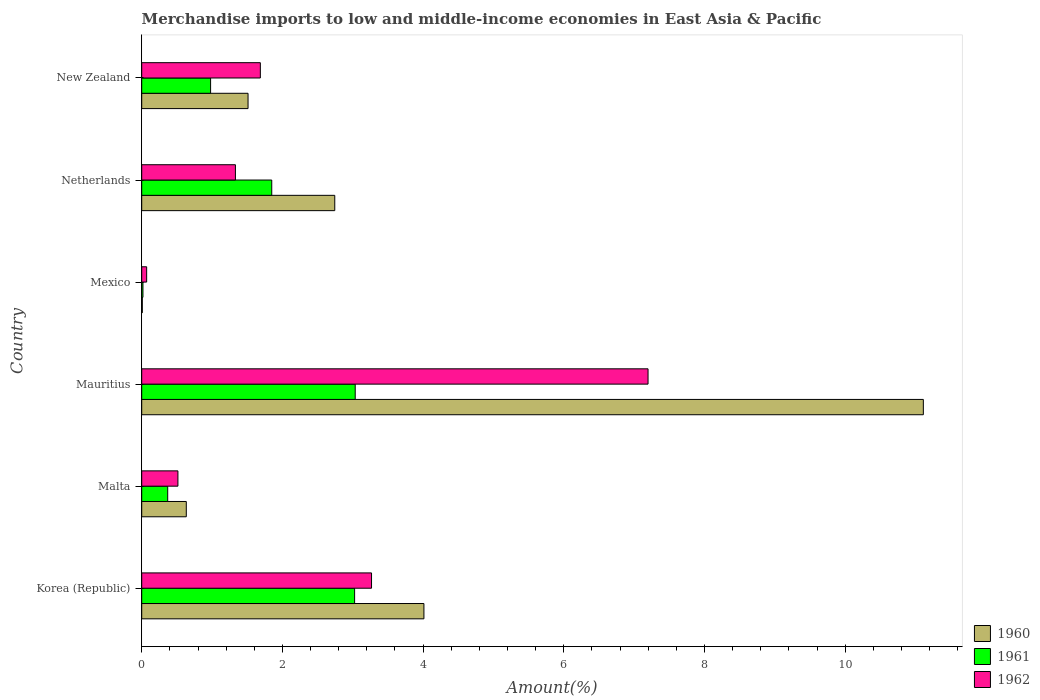How many different coloured bars are there?
Provide a succinct answer. 3. Are the number of bars on each tick of the Y-axis equal?
Provide a short and direct response. Yes. In how many cases, is the number of bars for a given country not equal to the number of legend labels?
Your answer should be very brief. 0. What is the percentage of amount earned from merchandise imports in 1961 in Netherlands?
Provide a short and direct response. 1.85. Across all countries, what is the maximum percentage of amount earned from merchandise imports in 1961?
Your response must be concise. 3.03. Across all countries, what is the minimum percentage of amount earned from merchandise imports in 1961?
Provide a succinct answer. 0.02. In which country was the percentage of amount earned from merchandise imports in 1960 maximum?
Your response must be concise. Mauritius. In which country was the percentage of amount earned from merchandise imports in 1961 minimum?
Provide a succinct answer. Mexico. What is the total percentage of amount earned from merchandise imports in 1960 in the graph?
Offer a terse response. 20.02. What is the difference between the percentage of amount earned from merchandise imports in 1961 in Malta and that in Netherlands?
Your answer should be compact. -1.48. What is the difference between the percentage of amount earned from merchandise imports in 1960 in Mexico and the percentage of amount earned from merchandise imports in 1961 in Korea (Republic)?
Your answer should be compact. -3.02. What is the average percentage of amount earned from merchandise imports in 1961 per country?
Your answer should be very brief. 1.55. What is the difference between the percentage of amount earned from merchandise imports in 1960 and percentage of amount earned from merchandise imports in 1961 in Netherlands?
Ensure brevity in your answer.  0.9. What is the ratio of the percentage of amount earned from merchandise imports in 1961 in Korea (Republic) to that in Mexico?
Ensure brevity in your answer.  171.92. Is the percentage of amount earned from merchandise imports in 1962 in Malta less than that in Mexico?
Provide a succinct answer. No. What is the difference between the highest and the second highest percentage of amount earned from merchandise imports in 1961?
Keep it short and to the point. 0.01. What is the difference between the highest and the lowest percentage of amount earned from merchandise imports in 1962?
Ensure brevity in your answer.  7.13. In how many countries, is the percentage of amount earned from merchandise imports in 1961 greater than the average percentage of amount earned from merchandise imports in 1961 taken over all countries?
Provide a short and direct response. 3. Are all the bars in the graph horizontal?
Your response must be concise. Yes. What is the difference between two consecutive major ticks on the X-axis?
Offer a very short reply. 2. Does the graph contain any zero values?
Provide a succinct answer. No. Where does the legend appear in the graph?
Provide a short and direct response. Bottom right. How are the legend labels stacked?
Make the answer very short. Vertical. What is the title of the graph?
Provide a succinct answer. Merchandise imports to low and middle-income economies in East Asia & Pacific. Does "1971" appear as one of the legend labels in the graph?
Provide a succinct answer. No. What is the label or title of the X-axis?
Your answer should be very brief. Amount(%). What is the Amount(%) in 1960 in Korea (Republic)?
Your response must be concise. 4.01. What is the Amount(%) of 1961 in Korea (Republic)?
Keep it short and to the point. 3.03. What is the Amount(%) in 1962 in Korea (Republic)?
Your answer should be compact. 3.27. What is the Amount(%) in 1960 in Malta?
Your answer should be very brief. 0.63. What is the Amount(%) in 1961 in Malta?
Keep it short and to the point. 0.37. What is the Amount(%) in 1962 in Malta?
Offer a terse response. 0.51. What is the Amount(%) of 1960 in Mauritius?
Ensure brevity in your answer.  11.11. What is the Amount(%) in 1961 in Mauritius?
Provide a short and direct response. 3.03. What is the Amount(%) of 1962 in Mauritius?
Offer a terse response. 7.2. What is the Amount(%) of 1960 in Mexico?
Offer a terse response. 0.01. What is the Amount(%) in 1961 in Mexico?
Offer a terse response. 0.02. What is the Amount(%) of 1962 in Mexico?
Provide a short and direct response. 0.07. What is the Amount(%) of 1960 in Netherlands?
Your answer should be very brief. 2.74. What is the Amount(%) of 1961 in Netherlands?
Keep it short and to the point. 1.85. What is the Amount(%) in 1962 in Netherlands?
Provide a succinct answer. 1.33. What is the Amount(%) in 1960 in New Zealand?
Ensure brevity in your answer.  1.51. What is the Amount(%) of 1961 in New Zealand?
Keep it short and to the point. 0.98. What is the Amount(%) of 1962 in New Zealand?
Make the answer very short. 1.69. Across all countries, what is the maximum Amount(%) of 1960?
Keep it short and to the point. 11.11. Across all countries, what is the maximum Amount(%) in 1961?
Keep it short and to the point. 3.03. Across all countries, what is the maximum Amount(%) in 1962?
Provide a short and direct response. 7.2. Across all countries, what is the minimum Amount(%) in 1960?
Offer a very short reply. 0.01. Across all countries, what is the minimum Amount(%) in 1961?
Offer a terse response. 0.02. Across all countries, what is the minimum Amount(%) of 1962?
Ensure brevity in your answer.  0.07. What is the total Amount(%) in 1960 in the graph?
Offer a terse response. 20.02. What is the total Amount(%) of 1961 in the graph?
Offer a very short reply. 9.28. What is the total Amount(%) in 1962 in the graph?
Provide a short and direct response. 14.07. What is the difference between the Amount(%) of 1960 in Korea (Republic) and that in Malta?
Ensure brevity in your answer.  3.38. What is the difference between the Amount(%) in 1961 in Korea (Republic) and that in Malta?
Your answer should be compact. 2.66. What is the difference between the Amount(%) in 1962 in Korea (Republic) and that in Malta?
Provide a short and direct response. 2.75. What is the difference between the Amount(%) of 1960 in Korea (Republic) and that in Mauritius?
Offer a terse response. -7.1. What is the difference between the Amount(%) in 1961 in Korea (Republic) and that in Mauritius?
Offer a very short reply. -0.01. What is the difference between the Amount(%) of 1962 in Korea (Republic) and that in Mauritius?
Your response must be concise. -3.93. What is the difference between the Amount(%) of 1960 in Korea (Republic) and that in Mexico?
Your answer should be very brief. 4. What is the difference between the Amount(%) in 1961 in Korea (Republic) and that in Mexico?
Provide a succinct answer. 3.01. What is the difference between the Amount(%) in 1962 in Korea (Republic) and that in Mexico?
Provide a succinct answer. 3.2. What is the difference between the Amount(%) in 1960 in Korea (Republic) and that in Netherlands?
Provide a short and direct response. 1.27. What is the difference between the Amount(%) in 1961 in Korea (Republic) and that in Netherlands?
Keep it short and to the point. 1.18. What is the difference between the Amount(%) in 1962 in Korea (Republic) and that in Netherlands?
Your answer should be very brief. 1.94. What is the difference between the Amount(%) in 1961 in Korea (Republic) and that in New Zealand?
Your response must be concise. 2.05. What is the difference between the Amount(%) in 1962 in Korea (Republic) and that in New Zealand?
Provide a succinct answer. 1.58. What is the difference between the Amount(%) of 1960 in Malta and that in Mauritius?
Give a very brief answer. -10.48. What is the difference between the Amount(%) in 1961 in Malta and that in Mauritius?
Ensure brevity in your answer.  -2.67. What is the difference between the Amount(%) of 1962 in Malta and that in Mauritius?
Provide a short and direct response. -6.68. What is the difference between the Amount(%) in 1960 in Malta and that in Mexico?
Your response must be concise. 0.63. What is the difference between the Amount(%) of 1961 in Malta and that in Mexico?
Ensure brevity in your answer.  0.35. What is the difference between the Amount(%) in 1962 in Malta and that in Mexico?
Offer a terse response. 0.44. What is the difference between the Amount(%) in 1960 in Malta and that in Netherlands?
Provide a short and direct response. -2.11. What is the difference between the Amount(%) in 1961 in Malta and that in Netherlands?
Offer a very short reply. -1.48. What is the difference between the Amount(%) in 1962 in Malta and that in Netherlands?
Provide a succinct answer. -0.82. What is the difference between the Amount(%) in 1960 in Malta and that in New Zealand?
Provide a short and direct response. -0.88. What is the difference between the Amount(%) of 1961 in Malta and that in New Zealand?
Your answer should be very brief. -0.61. What is the difference between the Amount(%) of 1962 in Malta and that in New Zealand?
Your answer should be compact. -1.17. What is the difference between the Amount(%) in 1960 in Mauritius and that in Mexico?
Ensure brevity in your answer.  11.1. What is the difference between the Amount(%) of 1961 in Mauritius and that in Mexico?
Offer a terse response. 3.02. What is the difference between the Amount(%) in 1962 in Mauritius and that in Mexico?
Your answer should be very brief. 7.13. What is the difference between the Amount(%) in 1960 in Mauritius and that in Netherlands?
Make the answer very short. 8.37. What is the difference between the Amount(%) in 1961 in Mauritius and that in Netherlands?
Your answer should be very brief. 1.19. What is the difference between the Amount(%) of 1962 in Mauritius and that in Netherlands?
Ensure brevity in your answer.  5.87. What is the difference between the Amount(%) of 1960 in Mauritius and that in New Zealand?
Offer a terse response. 9.6. What is the difference between the Amount(%) in 1961 in Mauritius and that in New Zealand?
Keep it short and to the point. 2.06. What is the difference between the Amount(%) in 1962 in Mauritius and that in New Zealand?
Ensure brevity in your answer.  5.51. What is the difference between the Amount(%) in 1960 in Mexico and that in Netherlands?
Make the answer very short. -2.74. What is the difference between the Amount(%) in 1961 in Mexico and that in Netherlands?
Your answer should be compact. -1.83. What is the difference between the Amount(%) of 1962 in Mexico and that in Netherlands?
Give a very brief answer. -1.26. What is the difference between the Amount(%) in 1960 in Mexico and that in New Zealand?
Offer a terse response. -1.5. What is the difference between the Amount(%) of 1961 in Mexico and that in New Zealand?
Offer a very short reply. -0.96. What is the difference between the Amount(%) of 1962 in Mexico and that in New Zealand?
Give a very brief answer. -1.62. What is the difference between the Amount(%) of 1960 in Netherlands and that in New Zealand?
Your answer should be compact. 1.23. What is the difference between the Amount(%) in 1961 in Netherlands and that in New Zealand?
Make the answer very short. 0.87. What is the difference between the Amount(%) of 1962 in Netherlands and that in New Zealand?
Keep it short and to the point. -0.35. What is the difference between the Amount(%) in 1960 in Korea (Republic) and the Amount(%) in 1961 in Malta?
Provide a short and direct response. 3.64. What is the difference between the Amount(%) of 1960 in Korea (Republic) and the Amount(%) of 1962 in Malta?
Make the answer very short. 3.5. What is the difference between the Amount(%) in 1961 in Korea (Republic) and the Amount(%) in 1962 in Malta?
Ensure brevity in your answer.  2.51. What is the difference between the Amount(%) of 1960 in Korea (Republic) and the Amount(%) of 1961 in Mauritius?
Your answer should be very brief. 0.98. What is the difference between the Amount(%) of 1960 in Korea (Republic) and the Amount(%) of 1962 in Mauritius?
Ensure brevity in your answer.  -3.19. What is the difference between the Amount(%) of 1961 in Korea (Republic) and the Amount(%) of 1962 in Mauritius?
Provide a succinct answer. -4.17. What is the difference between the Amount(%) of 1960 in Korea (Republic) and the Amount(%) of 1961 in Mexico?
Give a very brief answer. 3.99. What is the difference between the Amount(%) in 1960 in Korea (Republic) and the Amount(%) in 1962 in Mexico?
Your answer should be compact. 3.94. What is the difference between the Amount(%) in 1961 in Korea (Republic) and the Amount(%) in 1962 in Mexico?
Keep it short and to the point. 2.96. What is the difference between the Amount(%) of 1960 in Korea (Republic) and the Amount(%) of 1961 in Netherlands?
Your answer should be very brief. 2.16. What is the difference between the Amount(%) in 1960 in Korea (Republic) and the Amount(%) in 1962 in Netherlands?
Your response must be concise. 2.68. What is the difference between the Amount(%) in 1961 in Korea (Republic) and the Amount(%) in 1962 in Netherlands?
Your answer should be compact. 1.69. What is the difference between the Amount(%) of 1960 in Korea (Republic) and the Amount(%) of 1961 in New Zealand?
Provide a succinct answer. 3.03. What is the difference between the Amount(%) of 1960 in Korea (Republic) and the Amount(%) of 1962 in New Zealand?
Provide a succinct answer. 2.33. What is the difference between the Amount(%) in 1961 in Korea (Republic) and the Amount(%) in 1962 in New Zealand?
Keep it short and to the point. 1.34. What is the difference between the Amount(%) of 1960 in Malta and the Amount(%) of 1961 in Mauritius?
Make the answer very short. -2.4. What is the difference between the Amount(%) of 1960 in Malta and the Amount(%) of 1962 in Mauritius?
Keep it short and to the point. -6.56. What is the difference between the Amount(%) of 1961 in Malta and the Amount(%) of 1962 in Mauritius?
Ensure brevity in your answer.  -6.83. What is the difference between the Amount(%) of 1960 in Malta and the Amount(%) of 1961 in Mexico?
Your response must be concise. 0.62. What is the difference between the Amount(%) in 1960 in Malta and the Amount(%) in 1962 in Mexico?
Offer a very short reply. 0.56. What is the difference between the Amount(%) of 1961 in Malta and the Amount(%) of 1962 in Mexico?
Make the answer very short. 0.3. What is the difference between the Amount(%) in 1960 in Malta and the Amount(%) in 1961 in Netherlands?
Make the answer very short. -1.21. What is the difference between the Amount(%) of 1960 in Malta and the Amount(%) of 1962 in Netherlands?
Give a very brief answer. -0.7. What is the difference between the Amount(%) in 1961 in Malta and the Amount(%) in 1962 in Netherlands?
Offer a very short reply. -0.96. What is the difference between the Amount(%) in 1960 in Malta and the Amount(%) in 1961 in New Zealand?
Your answer should be very brief. -0.35. What is the difference between the Amount(%) of 1960 in Malta and the Amount(%) of 1962 in New Zealand?
Provide a short and direct response. -1.05. What is the difference between the Amount(%) in 1961 in Malta and the Amount(%) in 1962 in New Zealand?
Give a very brief answer. -1.32. What is the difference between the Amount(%) in 1960 in Mauritius and the Amount(%) in 1961 in Mexico?
Ensure brevity in your answer.  11.09. What is the difference between the Amount(%) of 1960 in Mauritius and the Amount(%) of 1962 in Mexico?
Your answer should be very brief. 11.04. What is the difference between the Amount(%) of 1961 in Mauritius and the Amount(%) of 1962 in Mexico?
Offer a terse response. 2.96. What is the difference between the Amount(%) of 1960 in Mauritius and the Amount(%) of 1961 in Netherlands?
Offer a very short reply. 9.26. What is the difference between the Amount(%) in 1960 in Mauritius and the Amount(%) in 1962 in Netherlands?
Keep it short and to the point. 9.78. What is the difference between the Amount(%) in 1961 in Mauritius and the Amount(%) in 1962 in Netherlands?
Make the answer very short. 1.7. What is the difference between the Amount(%) of 1960 in Mauritius and the Amount(%) of 1961 in New Zealand?
Your answer should be very brief. 10.13. What is the difference between the Amount(%) of 1960 in Mauritius and the Amount(%) of 1962 in New Zealand?
Keep it short and to the point. 9.42. What is the difference between the Amount(%) in 1961 in Mauritius and the Amount(%) in 1962 in New Zealand?
Make the answer very short. 1.35. What is the difference between the Amount(%) in 1960 in Mexico and the Amount(%) in 1961 in Netherlands?
Provide a succinct answer. -1.84. What is the difference between the Amount(%) of 1960 in Mexico and the Amount(%) of 1962 in Netherlands?
Give a very brief answer. -1.32. What is the difference between the Amount(%) in 1961 in Mexico and the Amount(%) in 1962 in Netherlands?
Provide a succinct answer. -1.31. What is the difference between the Amount(%) in 1960 in Mexico and the Amount(%) in 1961 in New Zealand?
Your answer should be very brief. -0.97. What is the difference between the Amount(%) in 1960 in Mexico and the Amount(%) in 1962 in New Zealand?
Offer a very short reply. -1.68. What is the difference between the Amount(%) in 1961 in Mexico and the Amount(%) in 1962 in New Zealand?
Your response must be concise. -1.67. What is the difference between the Amount(%) in 1960 in Netherlands and the Amount(%) in 1961 in New Zealand?
Give a very brief answer. 1.76. What is the difference between the Amount(%) in 1960 in Netherlands and the Amount(%) in 1962 in New Zealand?
Keep it short and to the point. 1.06. What is the difference between the Amount(%) of 1961 in Netherlands and the Amount(%) of 1962 in New Zealand?
Provide a short and direct response. 0.16. What is the average Amount(%) in 1960 per country?
Give a very brief answer. 3.34. What is the average Amount(%) in 1961 per country?
Provide a succinct answer. 1.55. What is the average Amount(%) in 1962 per country?
Make the answer very short. 2.34. What is the difference between the Amount(%) of 1960 and Amount(%) of 1961 in Korea (Republic)?
Your answer should be very brief. 0.99. What is the difference between the Amount(%) in 1960 and Amount(%) in 1962 in Korea (Republic)?
Offer a very short reply. 0.74. What is the difference between the Amount(%) in 1961 and Amount(%) in 1962 in Korea (Republic)?
Keep it short and to the point. -0.24. What is the difference between the Amount(%) of 1960 and Amount(%) of 1961 in Malta?
Your response must be concise. 0.26. What is the difference between the Amount(%) in 1960 and Amount(%) in 1962 in Malta?
Keep it short and to the point. 0.12. What is the difference between the Amount(%) in 1961 and Amount(%) in 1962 in Malta?
Provide a succinct answer. -0.15. What is the difference between the Amount(%) of 1960 and Amount(%) of 1961 in Mauritius?
Your answer should be compact. 8.08. What is the difference between the Amount(%) in 1960 and Amount(%) in 1962 in Mauritius?
Your response must be concise. 3.91. What is the difference between the Amount(%) in 1961 and Amount(%) in 1962 in Mauritius?
Your answer should be compact. -4.16. What is the difference between the Amount(%) of 1960 and Amount(%) of 1961 in Mexico?
Offer a very short reply. -0.01. What is the difference between the Amount(%) of 1960 and Amount(%) of 1962 in Mexico?
Your answer should be compact. -0.06. What is the difference between the Amount(%) of 1961 and Amount(%) of 1962 in Mexico?
Give a very brief answer. -0.05. What is the difference between the Amount(%) in 1960 and Amount(%) in 1961 in Netherlands?
Offer a terse response. 0.9. What is the difference between the Amount(%) in 1960 and Amount(%) in 1962 in Netherlands?
Provide a short and direct response. 1.41. What is the difference between the Amount(%) in 1961 and Amount(%) in 1962 in Netherlands?
Offer a very short reply. 0.52. What is the difference between the Amount(%) in 1960 and Amount(%) in 1961 in New Zealand?
Provide a succinct answer. 0.53. What is the difference between the Amount(%) in 1960 and Amount(%) in 1962 in New Zealand?
Provide a succinct answer. -0.17. What is the difference between the Amount(%) of 1961 and Amount(%) of 1962 in New Zealand?
Your answer should be compact. -0.71. What is the ratio of the Amount(%) in 1960 in Korea (Republic) to that in Malta?
Make the answer very short. 6.33. What is the ratio of the Amount(%) of 1961 in Korea (Republic) to that in Malta?
Make the answer very short. 8.19. What is the ratio of the Amount(%) of 1962 in Korea (Republic) to that in Malta?
Offer a very short reply. 6.35. What is the ratio of the Amount(%) in 1960 in Korea (Republic) to that in Mauritius?
Give a very brief answer. 0.36. What is the ratio of the Amount(%) in 1961 in Korea (Republic) to that in Mauritius?
Provide a short and direct response. 1. What is the ratio of the Amount(%) of 1962 in Korea (Republic) to that in Mauritius?
Provide a short and direct response. 0.45. What is the ratio of the Amount(%) in 1960 in Korea (Republic) to that in Mexico?
Offer a very short reply. 474.6. What is the ratio of the Amount(%) of 1961 in Korea (Republic) to that in Mexico?
Offer a terse response. 171.92. What is the ratio of the Amount(%) of 1962 in Korea (Republic) to that in Mexico?
Your answer should be very brief. 46.51. What is the ratio of the Amount(%) of 1960 in Korea (Republic) to that in Netherlands?
Make the answer very short. 1.46. What is the ratio of the Amount(%) in 1961 in Korea (Republic) to that in Netherlands?
Provide a short and direct response. 1.64. What is the ratio of the Amount(%) of 1962 in Korea (Republic) to that in Netherlands?
Your answer should be compact. 2.45. What is the ratio of the Amount(%) in 1960 in Korea (Republic) to that in New Zealand?
Keep it short and to the point. 2.65. What is the ratio of the Amount(%) of 1961 in Korea (Republic) to that in New Zealand?
Your answer should be compact. 3.09. What is the ratio of the Amount(%) of 1962 in Korea (Republic) to that in New Zealand?
Provide a short and direct response. 1.94. What is the ratio of the Amount(%) in 1960 in Malta to that in Mauritius?
Keep it short and to the point. 0.06. What is the ratio of the Amount(%) of 1961 in Malta to that in Mauritius?
Provide a succinct answer. 0.12. What is the ratio of the Amount(%) of 1962 in Malta to that in Mauritius?
Offer a very short reply. 0.07. What is the ratio of the Amount(%) of 1960 in Malta to that in Mexico?
Offer a terse response. 74.97. What is the ratio of the Amount(%) in 1961 in Malta to that in Mexico?
Your response must be concise. 20.99. What is the ratio of the Amount(%) in 1962 in Malta to that in Mexico?
Ensure brevity in your answer.  7.33. What is the ratio of the Amount(%) of 1960 in Malta to that in Netherlands?
Offer a very short reply. 0.23. What is the ratio of the Amount(%) of 1961 in Malta to that in Netherlands?
Make the answer very short. 0.2. What is the ratio of the Amount(%) in 1962 in Malta to that in Netherlands?
Make the answer very short. 0.39. What is the ratio of the Amount(%) in 1960 in Malta to that in New Zealand?
Your response must be concise. 0.42. What is the ratio of the Amount(%) in 1961 in Malta to that in New Zealand?
Give a very brief answer. 0.38. What is the ratio of the Amount(%) of 1962 in Malta to that in New Zealand?
Ensure brevity in your answer.  0.31. What is the ratio of the Amount(%) in 1960 in Mauritius to that in Mexico?
Ensure brevity in your answer.  1314.56. What is the ratio of the Amount(%) in 1961 in Mauritius to that in Mexico?
Ensure brevity in your answer.  172.41. What is the ratio of the Amount(%) in 1962 in Mauritius to that in Mexico?
Give a very brief answer. 102.48. What is the ratio of the Amount(%) in 1960 in Mauritius to that in Netherlands?
Give a very brief answer. 4.05. What is the ratio of the Amount(%) of 1961 in Mauritius to that in Netherlands?
Your answer should be compact. 1.64. What is the ratio of the Amount(%) of 1962 in Mauritius to that in Netherlands?
Your answer should be compact. 5.4. What is the ratio of the Amount(%) of 1960 in Mauritius to that in New Zealand?
Keep it short and to the point. 7.35. What is the ratio of the Amount(%) of 1961 in Mauritius to that in New Zealand?
Keep it short and to the point. 3.1. What is the ratio of the Amount(%) of 1962 in Mauritius to that in New Zealand?
Keep it short and to the point. 4.27. What is the ratio of the Amount(%) of 1960 in Mexico to that in Netherlands?
Provide a short and direct response. 0. What is the ratio of the Amount(%) of 1961 in Mexico to that in Netherlands?
Your answer should be very brief. 0.01. What is the ratio of the Amount(%) in 1962 in Mexico to that in Netherlands?
Your response must be concise. 0.05. What is the ratio of the Amount(%) in 1960 in Mexico to that in New Zealand?
Your answer should be compact. 0.01. What is the ratio of the Amount(%) of 1961 in Mexico to that in New Zealand?
Make the answer very short. 0.02. What is the ratio of the Amount(%) in 1962 in Mexico to that in New Zealand?
Provide a succinct answer. 0.04. What is the ratio of the Amount(%) of 1960 in Netherlands to that in New Zealand?
Your answer should be very brief. 1.82. What is the ratio of the Amount(%) of 1961 in Netherlands to that in New Zealand?
Provide a short and direct response. 1.89. What is the ratio of the Amount(%) of 1962 in Netherlands to that in New Zealand?
Your response must be concise. 0.79. What is the difference between the highest and the second highest Amount(%) of 1960?
Offer a terse response. 7.1. What is the difference between the highest and the second highest Amount(%) in 1961?
Keep it short and to the point. 0.01. What is the difference between the highest and the second highest Amount(%) in 1962?
Your answer should be compact. 3.93. What is the difference between the highest and the lowest Amount(%) of 1960?
Keep it short and to the point. 11.1. What is the difference between the highest and the lowest Amount(%) of 1961?
Ensure brevity in your answer.  3.02. What is the difference between the highest and the lowest Amount(%) of 1962?
Give a very brief answer. 7.13. 